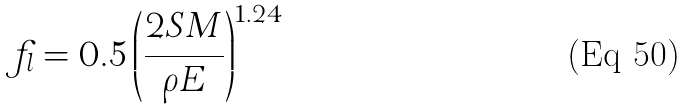<formula> <loc_0><loc_0><loc_500><loc_500>f _ { l } = 0 . 5 \left ( \frac { 2 S M } { \rho E } \right ) ^ { 1 . 2 4 }</formula> 